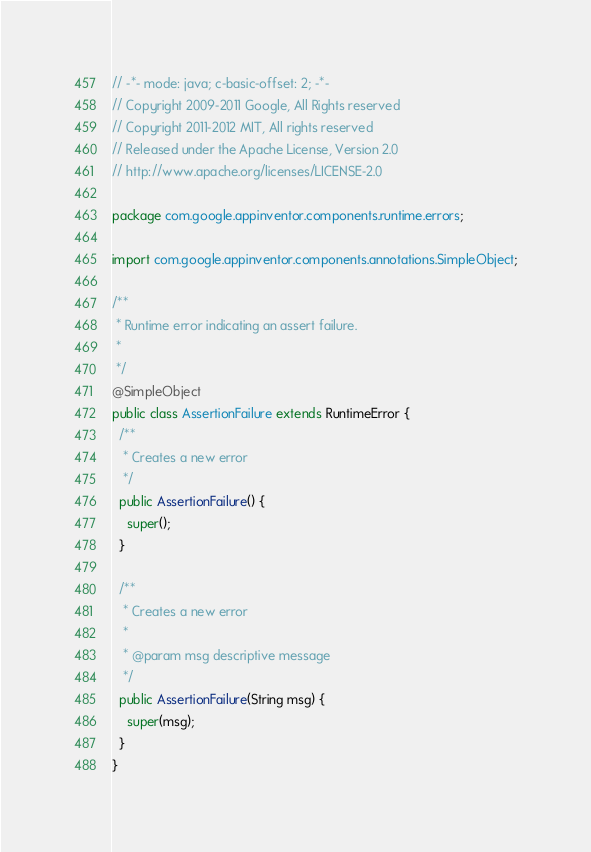Convert code to text. <code><loc_0><loc_0><loc_500><loc_500><_Java_>// -*- mode: java; c-basic-offset: 2; -*-
// Copyright 2009-2011 Google, All Rights reserved
// Copyright 2011-2012 MIT, All rights reserved
// Released under the Apache License, Version 2.0
// http://www.apache.org/licenses/LICENSE-2.0

package com.google.appinventor.components.runtime.errors;

import com.google.appinventor.components.annotations.SimpleObject;

/**
 * Runtime error indicating an assert failure.
 *
 */
@SimpleObject
public class AssertionFailure extends RuntimeError {
  /**
   * Creates a new error
   */
  public AssertionFailure() {
    super();
  }

  /**
   * Creates a new error
   *
   * @param msg descriptive message
   */
  public AssertionFailure(String msg) {
    super(msg);
  }
}
</code> 